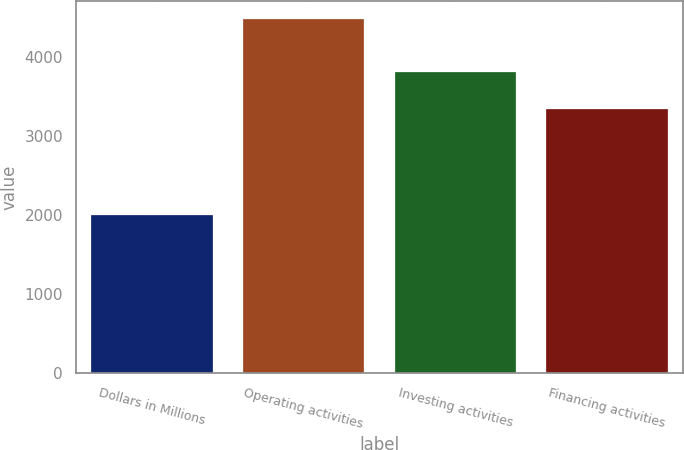Convert chart to OTSL. <chart><loc_0><loc_0><loc_500><loc_500><bar_chart><fcel>Dollars in Millions<fcel>Operating activities<fcel>Investing activities<fcel>Financing activities<nl><fcel>2010<fcel>4491<fcel>3812<fcel>3343<nl></chart> 